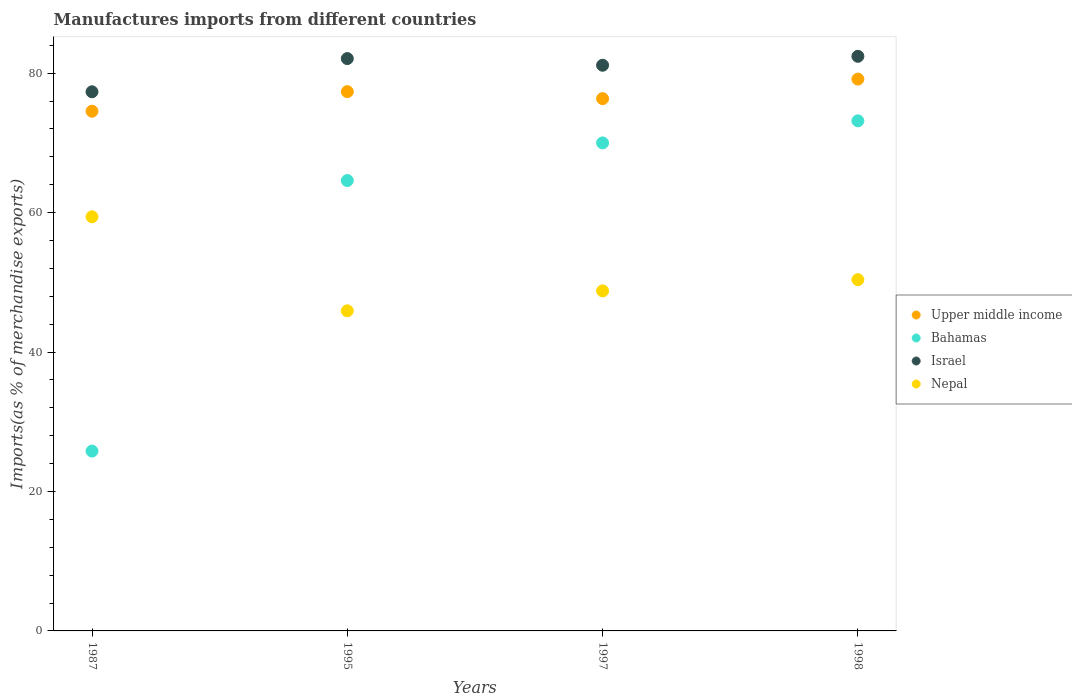What is the percentage of imports to different countries in Nepal in 1997?
Your response must be concise. 48.77. Across all years, what is the maximum percentage of imports to different countries in Nepal?
Provide a succinct answer. 59.4. Across all years, what is the minimum percentage of imports to different countries in Nepal?
Your answer should be compact. 45.91. In which year was the percentage of imports to different countries in Bahamas maximum?
Your response must be concise. 1998. What is the total percentage of imports to different countries in Israel in the graph?
Provide a short and direct response. 322.97. What is the difference between the percentage of imports to different countries in Bahamas in 1987 and that in 1998?
Offer a very short reply. -47.37. What is the difference between the percentage of imports to different countries in Nepal in 1998 and the percentage of imports to different countries in Bahamas in 1997?
Provide a short and direct response. -19.62. What is the average percentage of imports to different countries in Bahamas per year?
Provide a short and direct response. 58.39. In the year 1998, what is the difference between the percentage of imports to different countries in Bahamas and percentage of imports to different countries in Upper middle income?
Keep it short and to the point. -5.98. What is the ratio of the percentage of imports to different countries in Bahamas in 1995 to that in 1998?
Your answer should be compact. 0.88. What is the difference between the highest and the second highest percentage of imports to different countries in Upper middle income?
Your answer should be very brief. 1.8. What is the difference between the highest and the lowest percentage of imports to different countries in Israel?
Provide a short and direct response. 5.09. In how many years, is the percentage of imports to different countries in Upper middle income greater than the average percentage of imports to different countries in Upper middle income taken over all years?
Give a very brief answer. 2. Is the sum of the percentage of imports to different countries in Israel in 1997 and 1998 greater than the maximum percentage of imports to different countries in Bahamas across all years?
Make the answer very short. Yes. Does the percentage of imports to different countries in Upper middle income monotonically increase over the years?
Provide a succinct answer. No. Is the percentage of imports to different countries in Israel strictly greater than the percentage of imports to different countries in Bahamas over the years?
Keep it short and to the point. Yes. Is the percentage of imports to different countries in Nepal strictly less than the percentage of imports to different countries in Bahamas over the years?
Give a very brief answer. No. What is the difference between two consecutive major ticks on the Y-axis?
Make the answer very short. 20. Are the values on the major ticks of Y-axis written in scientific E-notation?
Offer a terse response. No. Does the graph contain grids?
Provide a short and direct response. No. What is the title of the graph?
Keep it short and to the point. Manufactures imports from different countries. Does "Madagascar" appear as one of the legend labels in the graph?
Your response must be concise. No. What is the label or title of the Y-axis?
Offer a terse response. Imports(as % of merchandise exports). What is the Imports(as % of merchandise exports) in Upper middle income in 1987?
Provide a succinct answer. 74.54. What is the Imports(as % of merchandise exports) in Bahamas in 1987?
Your answer should be compact. 25.79. What is the Imports(as % of merchandise exports) in Israel in 1987?
Provide a short and direct response. 77.33. What is the Imports(as % of merchandise exports) in Nepal in 1987?
Provide a short and direct response. 59.4. What is the Imports(as % of merchandise exports) in Upper middle income in 1995?
Provide a succinct answer. 77.35. What is the Imports(as % of merchandise exports) of Bahamas in 1995?
Give a very brief answer. 64.6. What is the Imports(as % of merchandise exports) in Israel in 1995?
Provide a short and direct response. 82.09. What is the Imports(as % of merchandise exports) of Nepal in 1995?
Keep it short and to the point. 45.91. What is the Imports(as % of merchandise exports) of Upper middle income in 1997?
Your answer should be compact. 76.35. What is the Imports(as % of merchandise exports) of Bahamas in 1997?
Your answer should be very brief. 70. What is the Imports(as % of merchandise exports) of Israel in 1997?
Give a very brief answer. 81.13. What is the Imports(as % of merchandise exports) of Nepal in 1997?
Ensure brevity in your answer.  48.77. What is the Imports(as % of merchandise exports) in Upper middle income in 1998?
Provide a short and direct response. 79.15. What is the Imports(as % of merchandise exports) in Bahamas in 1998?
Offer a very short reply. 73.16. What is the Imports(as % of merchandise exports) in Israel in 1998?
Your response must be concise. 82.42. What is the Imports(as % of merchandise exports) in Nepal in 1998?
Provide a short and direct response. 50.38. Across all years, what is the maximum Imports(as % of merchandise exports) in Upper middle income?
Your answer should be compact. 79.15. Across all years, what is the maximum Imports(as % of merchandise exports) in Bahamas?
Your response must be concise. 73.16. Across all years, what is the maximum Imports(as % of merchandise exports) in Israel?
Provide a short and direct response. 82.42. Across all years, what is the maximum Imports(as % of merchandise exports) in Nepal?
Offer a terse response. 59.4. Across all years, what is the minimum Imports(as % of merchandise exports) in Upper middle income?
Provide a succinct answer. 74.54. Across all years, what is the minimum Imports(as % of merchandise exports) of Bahamas?
Your answer should be very brief. 25.79. Across all years, what is the minimum Imports(as % of merchandise exports) in Israel?
Provide a succinct answer. 77.33. Across all years, what is the minimum Imports(as % of merchandise exports) of Nepal?
Ensure brevity in your answer.  45.91. What is the total Imports(as % of merchandise exports) in Upper middle income in the graph?
Keep it short and to the point. 307.39. What is the total Imports(as % of merchandise exports) in Bahamas in the graph?
Give a very brief answer. 233.55. What is the total Imports(as % of merchandise exports) of Israel in the graph?
Your response must be concise. 322.97. What is the total Imports(as % of merchandise exports) of Nepal in the graph?
Provide a short and direct response. 204.46. What is the difference between the Imports(as % of merchandise exports) of Upper middle income in 1987 and that in 1995?
Your response must be concise. -2.81. What is the difference between the Imports(as % of merchandise exports) in Bahamas in 1987 and that in 1995?
Give a very brief answer. -38.8. What is the difference between the Imports(as % of merchandise exports) of Israel in 1987 and that in 1995?
Offer a terse response. -4.76. What is the difference between the Imports(as % of merchandise exports) of Nepal in 1987 and that in 1995?
Offer a terse response. 13.48. What is the difference between the Imports(as % of merchandise exports) in Upper middle income in 1987 and that in 1997?
Provide a succinct answer. -1.8. What is the difference between the Imports(as % of merchandise exports) in Bahamas in 1987 and that in 1997?
Give a very brief answer. -44.2. What is the difference between the Imports(as % of merchandise exports) in Israel in 1987 and that in 1997?
Ensure brevity in your answer.  -3.81. What is the difference between the Imports(as % of merchandise exports) in Nepal in 1987 and that in 1997?
Your response must be concise. 10.62. What is the difference between the Imports(as % of merchandise exports) in Upper middle income in 1987 and that in 1998?
Offer a very short reply. -4.61. What is the difference between the Imports(as % of merchandise exports) of Bahamas in 1987 and that in 1998?
Ensure brevity in your answer.  -47.37. What is the difference between the Imports(as % of merchandise exports) in Israel in 1987 and that in 1998?
Offer a very short reply. -5.09. What is the difference between the Imports(as % of merchandise exports) in Nepal in 1987 and that in 1998?
Provide a short and direct response. 9.02. What is the difference between the Imports(as % of merchandise exports) in Upper middle income in 1995 and that in 1997?
Your response must be concise. 1.01. What is the difference between the Imports(as % of merchandise exports) in Bahamas in 1995 and that in 1997?
Your answer should be compact. -5.4. What is the difference between the Imports(as % of merchandise exports) in Israel in 1995 and that in 1997?
Provide a succinct answer. 0.96. What is the difference between the Imports(as % of merchandise exports) in Nepal in 1995 and that in 1997?
Offer a terse response. -2.86. What is the difference between the Imports(as % of merchandise exports) in Upper middle income in 1995 and that in 1998?
Provide a short and direct response. -1.8. What is the difference between the Imports(as % of merchandise exports) in Bahamas in 1995 and that in 1998?
Keep it short and to the point. -8.57. What is the difference between the Imports(as % of merchandise exports) in Israel in 1995 and that in 1998?
Provide a succinct answer. -0.33. What is the difference between the Imports(as % of merchandise exports) of Nepal in 1995 and that in 1998?
Give a very brief answer. -4.46. What is the difference between the Imports(as % of merchandise exports) in Upper middle income in 1997 and that in 1998?
Offer a terse response. -2.8. What is the difference between the Imports(as % of merchandise exports) of Bahamas in 1997 and that in 1998?
Ensure brevity in your answer.  -3.17. What is the difference between the Imports(as % of merchandise exports) of Israel in 1997 and that in 1998?
Give a very brief answer. -1.28. What is the difference between the Imports(as % of merchandise exports) of Nepal in 1997 and that in 1998?
Make the answer very short. -1.61. What is the difference between the Imports(as % of merchandise exports) of Upper middle income in 1987 and the Imports(as % of merchandise exports) of Bahamas in 1995?
Give a very brief answer. 9.95. What is the difference between the Imports(as % of merchandise exports) of Upper middle income in 1987 and the Imports(as % of merchandise exports) of Israel in 1995?
Your response must be concise. -7.55. What is the difference between the Imports(as % of merchandise exports) of Upper middle income in 1987 and the Imports(as % of merchandise exports) of Nepal in 1995?
Make the answer very short. 28.63. What is the difference between the Imports(as % of merchandise exports) of Bahamas in 1987 and the Imports(as % of merchandise exports) of Israel in 1995?
Your response must be concise. -56.3. What is the difference between the Imports(as % of merchandise exports) of Bahamas in 1987 and the Imports(as % of merchandise exports) of Nepal in 1995?
Give a very brief answer. -20.12. What is the difference between the Imports(as % of merchandise exports) of Israel in 1987 and the Imports(as % of merchandise exports) of Nepal in 1995?
Keep it short and to the point. 31.41. What is the difference between the Imports(as % of merchandise exports) of Upper middle income in 1987 and the Imports(as % of merchandise exports) of Bahamas in 1997?
Provide a succinct answer. 4.55. What is the difference between the Imports(as % of merchandise exports) of Upper middle income in 1987 and the Imports(as % of merchandise exports) of Israel in 1997?
Your answer should be very brief. -6.59. What is the difference between the Imports(as % of merchandise exports) of Upper middle income in 1987 and the Imports(as % of merchandise exports) of Nepal in 1997?
Ensure brevity in your answer.  25.77. What is the difference between the Imports(as % of merchandise exports) in Bahamas in 1987 and the Imports(as % of merchandise exports) in Israel in 1997?
Offer a very short reply. -55.34. What is the difference between the Imports(as % of merchandise exports) of Bahamas in 1987 and the Imports(as % of merchandise exports) of Nepal in 1997?
Offer a very short reply. -22.98. What is the difference between the Imports(as % of merchandise exports) of Israel in 1987 and the Imports(as % of merchandise exports) of Nepal in 1997?
Provide a short and direct response. 28.56. What is the difference between the Imports(as % of merchandise exports) of Upper middle income in 1987 and the Imports(as % of merchandise exports) of Bahamas in 1998?
Give a very brief answer. 1.38. What is the difference between the Imports(as % of merchandise exports) of Upper middle income in 1987 and the Imports(as % of merchandise exports) of Israel in 1998?
Provide a short and direct response. -7.87. What is the difference between the Imports(as % of merchandise exports) of Upper middle income in 1987 and the Imports(as % of merchandise exports) of Nepal in 1998?
Ensure brevity in your answer.  24.16. What is the difference between the Imports(as % of merchandise exports) in Bahamas in 1987 and the Imports(as % of merchandise exports) in Israel in 1998?
Give a very brief answer. -56.62. What is the difference between the Imports(as % of merchandise exports) of Bahamas in 1987 and the Imports(as % of merchandise exports) of Nepal in 1998?
Your answer should be very brief. -24.58. What is the difference between the Imports(as % of merchandise exports) in Israel in 1987 and the Imports(as % of merchandise exports) in Nepal in 1998?
Provide a succinct answer. 26.95. What is the difference between the Imports(as % of merchandise exports) in Upper middle income in 1995 and the Imports(as % of merchandise exports) in Bahamas in 1997?
Your answer should be very brief. 7.36. What is the difference between the Imports(as % of merchandise exports) of Upper middle income in 1995 and the Imports(as % of merchandise exports) of Israel in 1997?
Your answer should be compact. -3.78. What is the difference between the Imports(as % of merchandise exports) of Upper middle income in 1995 and the Imports(as % of merchandise exports) of Nepal in 1997?
Ensure brevity in your answer.  28.58. What is the difference between the Imports(as % of merchandise exports) of Bahamas in 1995 and the Imports(as % of merchandise exports) of Israel in 1997?
Provide a succinct answer. -16.54. What is the difference between the Imports(as % of merchandise exports) in Bahamas in 1995 and the Imports(as % of merchandise exports) in Nepal in 1997?
Keep it short and to the point. 15.82. What is the difference between the Imports(as % of merchandise exports) in Israel in 1995 and the Imports(as % of merchandise exports) in Nepal in 1997?
Your response must be concise. 33.32. What is the difference between the Imports(as % of merchandise exports) in Upper middle income in 1995 and the Imports(as % of merchandise exports) in Bahamas in 1998?
Keep it short and to the point. 4.19. What is the difference between the Imports(as % of merchandise exports) of Upper middle income in 1995 and the Imports(as % of merchandise exports) of Israel in 1998?
Your answer should be very brief. -5.07. What is the difference between the Imports(as % of merchandise exports) in Upper middle income in 1995 and the Imports(as % of merchandise exports) in Nepal in 1998?
Give a very brief answer. 26.97. What is the difference between the Imports(as % of merchandise exports) of Bahamas in 1995 and the Imports(as % of merchandise exports) of Israel in 1998?
Your answer should be compact. -17.82. What is the difference between the Imports(as % of merchandise exports) of Bahamas in 1995 and the Imports(as % of merchandise exports) of Nepal in 1998?
Give a very brief answer. 14.22. What is the difference between the Imports(as % of merchandise exports) of Israel in 1995 and the Imports(as % of merchandise exports) of Nepal in 1998?
Keep it short and to the point. 31.71. What is the difference between the Imports(as % of merchandise exports) in Upper middle income in 1997 and the Imports(as % of merchandise exports) in Bahamas in 1998?
Provide a succinct answer. 3.18. What is the difference between the Imports(as % of merchandise exports) in Upper middle income in 1997 and the Imports(as % of merchandise exports) in Israel in 1998?
Provide a succinct answer. -6.07. What is the difference between the Imports(as % of merchandise exports) in Upper middle income in 1997 and the Imports(as % of merchandise exports) in Nepal in 1998?
Give a very brief answer. 25.97. What is the difference between the Imports(as % of merchandise exports) in Bahamas in 1997 and the Imports(as % of merchandise exports) in Israel in 1998?
Provide a short and direct response. -12.42. What is the difference between the Imports(as % of merchandise exports) in Bahamas in 1997 and the Imports(as % of merchandise exports) in Nepal in 1998?
Your answer should be very brief. 19.62. What is the difference between the Imports(as % of merchandise exports) in Israel in 1997 and the Imports(as % of merchandise exports) in Nepal in 1998?
Your response must be concise. 30.76. What is the average Imports(as % of merchandise exports) of Upper middle income per year?
Your answer should be compact. 76.85. What is the average Imports(as % of merchandise exports) of Bahamas per year?
Give a very brief answer. 58.39. What is the average Imports(as % of merchandise exports) in Israel per year?
Your answer should be compact. 80.74. What is the average Imports(as % of merchandise exports) of Nepal per year?
Keep it short and to the point. 51.11. In the year 1987, what is the difference between the Imports(as % of merchandise exports) of Upper middle income and Imports(as % of merchandise exports) of Bahamas?
Provide a short and direct response. 48.75. In the year 1987, what is the difference between the Imports(as % of merchandise exports) of Upper middle income and Imports(as % of merchandise exports) of Israel?
Make the answer very short. -2.79. In the year 1987, what is the difference between the Imports(as % of merchandise exports) in Upper middle income and Imports(as % of merchandise exports) in Nepal?
Keep it short and to the point. 15.15. In the year 1987, what is the difference between the Imports(as % of merchandise exports) of Bahamas and Imports(as % of merchandise exports) of Israel?
Ensure brevity in your answer.  -51.53. In the year 1987, what is the difference between the Imports(as % of merchandise exports) of Bahamas and Imports(as % of merchandise exports) of Nepal?
Ensure brevity in your answer.  -33.6. In the year 1987, what is the difference between the Imports(as % of merchandise exports) in Israel and Imports(as % of merchandise exports) in Nepal?
Your answer should be compact. 17.93. In the year 1995, what is the difference between the Imports(as % of merchandise exports) of Upper middle income and Imports(as % of merchandise exports) of Bahamas?
Your answer should be very brief. 12.76. In the year 1995, what is the difference between the Imports(as % of merchandise exports) in Upper middle income and Imports(as % of merchandise exports) in Israel?
Keep it short and to the point. -4.74. In the year 1995, what is the difference between the Imports(as % of merchandise exports) of Upper middle income and Imports(as % of merchandise exports) of Nepal?
Give a very brief answer. 31.44. In the year 1995, what is the difference between the Imports(as % of merchandise exports) of Bahamas and Imports(as % of merchandise exports) of Israel?
Provide a short and direct response. -17.49. In the year 1995, what is the difference between the Imports(as % of merchandise exports) in Bahamas and Imports(as % of merchandise exports) in Nepal?
Make the answer very short. 18.68. In the year 1995, what is the difference between the Imports(as % of merchandise exports) of Israel and Imports(as % of merchandise exports) of Nepal?
Offer a very short reply. 36.18. In the year 1997, what is the difference between the Imports(as % of merchandise exports) of Upper middle income and Imports(as % of merchandise exports) of Bahamas?
Your response must be concise. 6.35. In the year 1997, what is the difference between the Imports(as % of merchandise exports) of Upper middle income and Imports(as % of merchandise exports) of Israel?
Your response must be concise. -4.79. In the year 1997, what is the difference between the Imports(as % of merchandise exports) in Upper middle income and Imports(as % of merchandise exports) in Nepal?
Offer a terse response. 27.57. In the year 1997, what is the difference between the Imports(as % of merchandise exports) of Bahamas and Imports(as % of merchandise exports) of Israel?
Keep it short and to the point. -11.14. In the year 1997, what is the difference between the Imports(as % of merchandise exports) in Bahamas and Imports(as % of merchandise exports) in Nepal?
Ensure brevity in your answer.  21.22. In the year 1997, what is the difference between the Imports(as % of merchandise exports) in Israel and Imports(as % of merchandise exports) in Nepal?
Offer a very short reply. 32.36. In the year 1998, what is the difference between the Imports(as % of merchandise exports) of Upper middle income and Imports(as % of merchandise exports) of Bahamas?
Ensure brevity in your answer.  5.98. In the year 1998, what is the difference between the Imports(as % of merchandise exports) of Upper middle income and Imports(as % of merchandise exports) of Israel?
Provide a succinct answer. -3.27. In the year 1998, what is the difference between the Imports(as % of merchandise exports) of Upper middle income and Imports(as % of merchandise exports) of Nepal?
Offer a very short reply. 28.77. In the year 1998, what is the difference between the Imports(as % of merchandise exports) in Bahamas and Imports(as % of merchandise exports) in Israel?
Make the answer very short. -9.25. In the year 1998, what is the difference between the Imports(as % of merchandise exports) of Bahamas and Imports(as % of merchandise exports) of Nepal?
Give a very brief answer. 22.78. In the year 1998, what is the difference between the Imports(as % of merchandise exports) of Israel and Imports(as % of merchandise exports) of Nepal?
Your answer should be compact. 32.04. What is the ratio of the Imports(as % of merchandise exports) in Upper middle income in 1987 to that in 1995?
Your answer should be very brief. 0.96. What is the ratio of the Imports(as % of merchandise exports) of Bahamas in 1987 to that in 1995?
Your answer should be very brief. 0.4. What is the ratio of the Imports(as % of merchandise exports) of Israel in 1987 to that in 1995?
Your answer should be compact. 0.94. What is the ratio of the Imports(as % of merchandise exports) of Nepal in 1987 to that in 1995?
Offer a terse response. 1.29. What is the ratio of the Imports(as % of merchandise exports) in Upper middle income in 1987 to that in 1997?
Your answer should be compact. 0.98. What is the ratio of the Imports(as % of merchandise exports) in Bahamas in 1987 to that in 1997?
Provide a short and direct response. 0.37. What is the ratio of the Imports(as % of merchandise exports) in Israel in 1987 to that in 1997?
Give a very brief answer. 0.95. What is the ratio of the Imports(as % of merchandise exports) of Nepal in 1987 to that in 1997?
Your answer should be compact. 1.22. What is the ratio of the Imports(as % of merchandise exports) in Upper middle income in 1987 to that in 1998?
Keep it short and to the point. 0.94. What is the ratio of the Imports(as % of merchandise exports) in Bahamas in 1987 to that in 1998?
Offer a terse response. 0.35. What is the ratio of the Imports(as % of merchandise exports) of Israel in 1987 to that in 1998?
Provide a succinct answer. 0.94. What is the ratio of the Imports(as % of merchandise exports) in Nepal in 1987 to that in 1998?
Provide a succinct answer. 1.18. What is the ratio of the Imports(as % of merchandise exports) in Upper middle income in 1995 to that in 1997?
Give a very brief answer. 1.01. What is the ratio of the Imports(as % of merchandise exports) in Bahamas in 1995 to that in 1997?
Provide a succinct answer. 0.92. What is the ratio of the Imports(as % of merchandise exports) of Israel in 1995 to that in 1997?
Ensure brevity in your answer.  1.01. What is the ratio of the Imports(as % of merchandise exports) of Nepal in 1995 to that in 1997?
Your response must be concise. 0.94. What is the ratio of the Imports(as % of merchandise exports) of Upper middle income in 1995 to that in 1998?
Keep it short and to the point. 0.98. What is the ratio of the Imports(as % of merchandise exports) in Bahamas in 1995 to that in 1998?
Give a very brief answer. 0.88. What is the ratio of the Imports(as % of merchandise exports) in Israel in 1995 to that in 1998?
Provide a succinct answer. 1. What is the ratio of the Imports(as % of merchandise exports) of Nepal in 1995 to that in 1998?
Offer a very short reply. 0.91. What is the ratio of the Imports(as % of merchandise exports) of Upper middle income in 1997 to that in 1998?
Ensure brevity in your answer.  0.96. What is the ratio of the Imports(as % of merchandise exports) in Bahamas in 1997 to that in 1998?
Your answer should be very brief. 0.96. What is the ratio of the Imports(as % of merchandise exports) of Israel in 1997 to that in 1998?
Your response must be concise. 0.98. What is the ratio of the Imports(as % of merchandise exports) in Nepal in 1997 to that in 1998?
Your answer should be very brief. 0.97. What is the difference between the highest and the second highest Imports(as % of merchandise exports) in Upper middle income?
Keep it short and to the point. 1.8. What is the difference between the highest and the second highest Imports(as % of merchandise exports) of Bahamas?
Provide a succinct answer. 3.17. What is the difference between the highest and the second highest Imports(as % of merchandise exports) in Israel?
Make the answer very short. 0.33. What is the difference between the highest and the second highest Imports(as % of merchandise exports) of Nepal?
Your answer should be compact. 9.02. What is the difference between the highest and the lowest Imports(as % of merchandise exports) of Upper middle income?
Make the answer very short. 4.61. What is the difference between the highest and the lowest Imports(as % of merchandise exports) of Bahamas?
Provide a short and direct response. 47.37. What is the difference between the highest and the lowest Imports(as % of merchandise exports) in Israel?
Offer a very short reply. 5.09. What is the difference between the highest and the lowest Imports(as % of merchandise exports) in Nepal?
Make the answer very short. 13.48. 